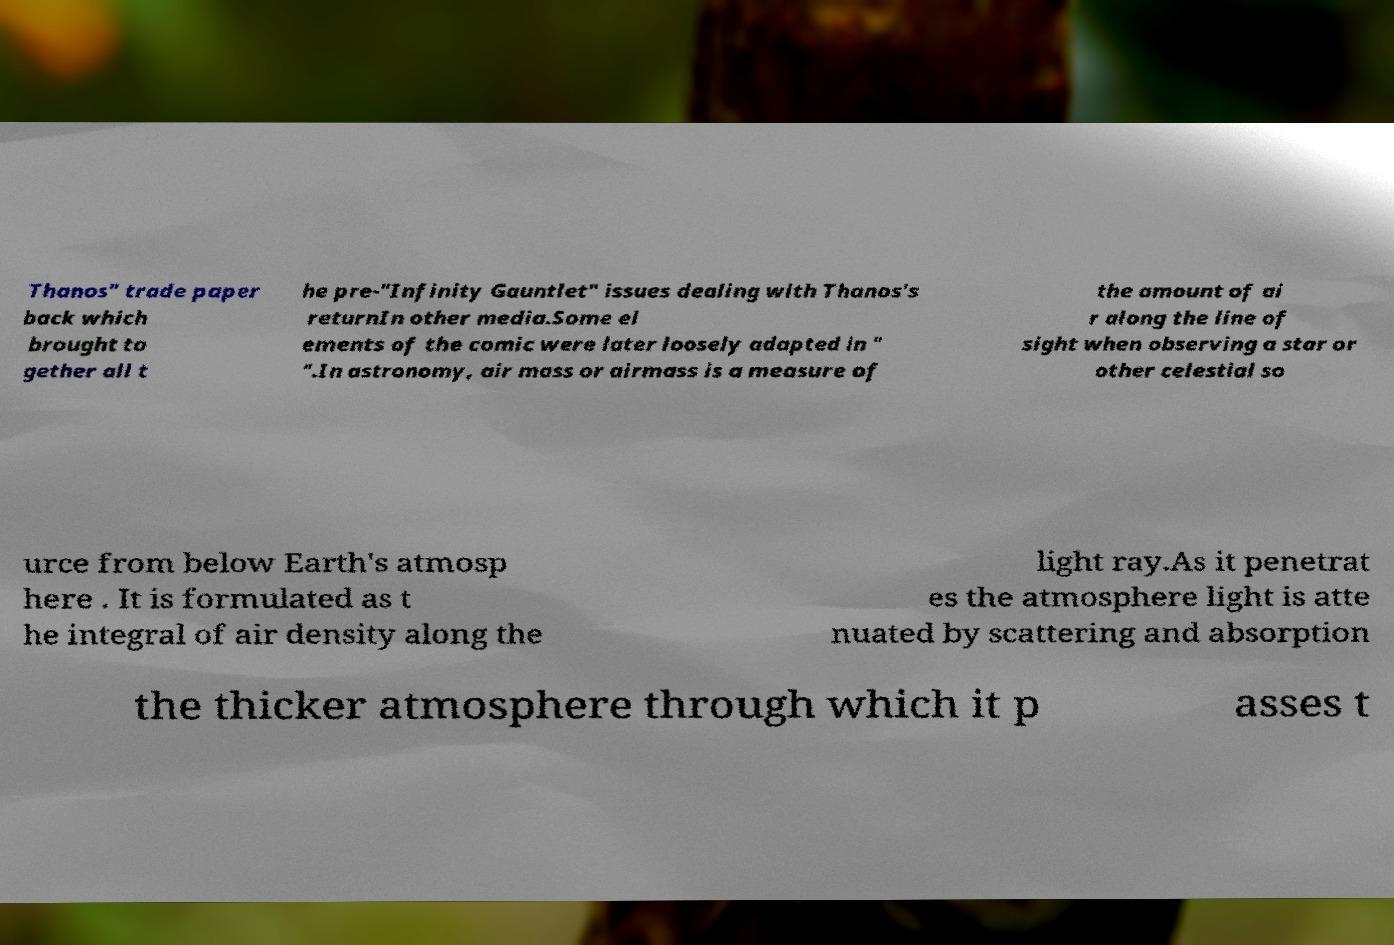Could you assist in decoding the text presented in this image and type it out clearly? Thanos" trade paper back which brought to gether all t he pre-"Infinity Gauntlet" issues dealing with Thanos's returnIn other media.Some el ements of the comic were later loosely adapted in " ".In astronomy, air mass or airmass is a measure of the amount of ai r along the line of sight when observing a star or other celestial so urce from below Earth's atmosp here . It is formulated as t he integral of air density along the light ray.As it penetrat es the atmosphere light is atte nuated by scattering and absorption the thicker atmosphere through which it p asses t 